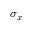<formula> <loc_0><loc_0><loc_500><loc_500>\sigma _ { x }</formula> 